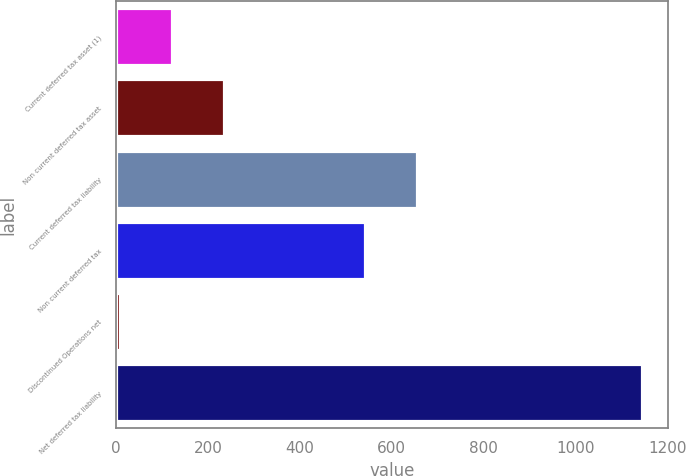Convert chart. <chart><loc_0><loc_0><loc_500><loc_500><bar_chart><fcel>Current deferred tax asset (1)<fcel>Non current deferred tax asset<fcel>Current deferred tax liability<fcel>Non current deferred tax<fcel>Discontinued Operations net<fcel>Net deferred tax liability<nl><fcel>122.03<fcel>235.66<fcel>654.63<fcel>541<fcel>8.4<fcel>1144.7<nl></chart> 